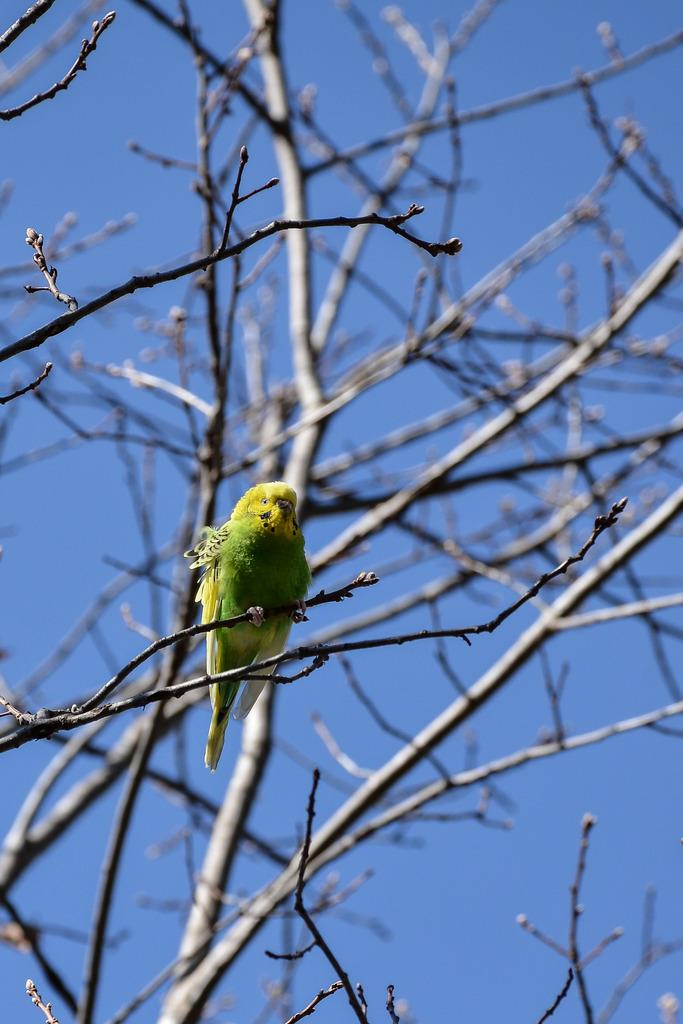What type of animal is in the image? There is a parrot in the image. Where is the parrot located? The parrot is on a dry tree. What type of trousers is the parrot wearing in the image? Parrots do not wear trousers, so this detail cannot be found in the image. 